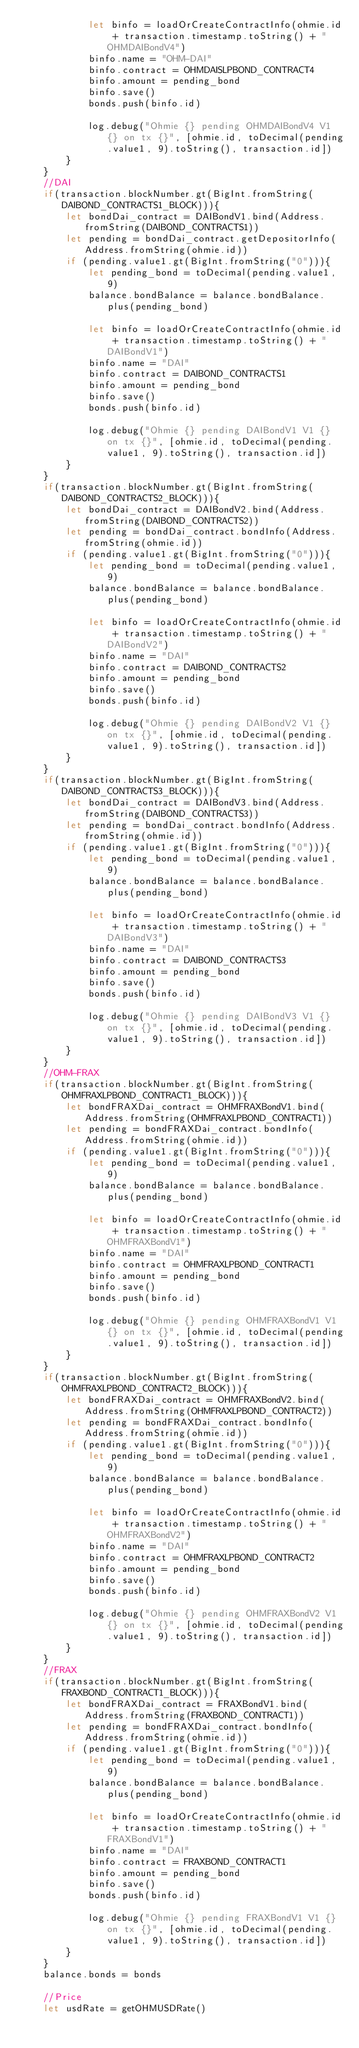<code> <loc_0><loc_0><loc_500><loc_500><_TypeScript_>            let binfo = loadOrCreateContractInfo(ohmie.id + transaction.timestamp.toString() + "OHMDAIBondV4")
            binfo.name = "OHM-DAI"
            binfo.contract = OHMDAISLPBOND_CONTRACT4
            binfo.amount = pending_bond
            binfo.save()
            bonds.push(binfo.id)

            log.debug("Ohmie {} pending OHMDAIBondV4 V1 {} on tx {}", [ohmie.id, toDecimal(pending.value1, 9).toString(), transaction.id])
        }
    }
    //DAI
    if(transaction.blockNumber.gt(BigInt.fromString(DAIBOND_CONTRACTS1_BLOCK))){
        let bondDai_contract = DAIBondV1.bind(Address.fromString(DAIBOND_CONTRACTS1))
        let pending = bondDai_contract.getDepositorInfo(Address.fromString(ohmie.id))
        if (pending.value1.gt(BigInt.fromString("0"))){
            let pending_bond = toDecimal(pending.value1, 9)
            balance.bondBalance = balance.bondBalance.plus(pending_bond)

            let binfo = loadOrCreateContractInfo(ohmie.id + transaction.timestamp.toString() + "DAIBondV1")
            binfo.name = "DAI"
            binfo.contract = DAIBOND_CONTRACTS1
            binfo.amount = pending_bond
            binfo.save()
            bonds.push(binfo.id)

            log.debug("Ohmie {} pending DAIBondV1 V1 {} on tx {}", [ohmie.id, toDecimal(pending.value1, 9).toString(), transaction.id])
        }
    }
    if(transaction.blockNumber.gt(BigInt.fromString(DAIBOND_CONTRACTS2_BLOCK))){
        let bondDai_contract = DAIBondV2.bind(Address.fromString(DAIBOND_CONTRACTS2))
        let pending = bondDai_contract.bondInfo(Address.fromString(ohmie.id))
        if (pending.value1.gt(BigInt.fromString("0"))){
            let pending_bond = toDecimal(pending.value1, 9)
            balance.bondBalance = balance.bondBalance.plus(pending_bond)

            let binfo = loadOrCreateContractInfo(ohmie.id + transaction.timestamp.toString() + "DAIBondV2")
            binfo.name = "DAI"
            binfo.contract = DAIBOND_CONTRACTS2
            binfo.amount = pending_bond
            binfo.save()
            bonds.push(binfo.id)

            log.debug("Ohmie {} pending DAIBondV2 V1 {} on tx {}", [ohmie.id, toDecimal(pending.value1, 9).toString(), transaction.id])
        }
    }
    if(transaction.blockNumber.gt(BigInt.fromString(DAIBOND_CONTRACTS3_BLOCK))){
        let bondDai_contract = DAIBondV3.bind(Address.fromString(DAIBOND_CONTRACTS3))
        let pending = bondDai_contract.bondInfo(Address.fromString(ohmie.id))
        if (pending.value1.gt(BigInt.fromString("0"))){
            let pending_bond = toDecimal(pending.value1, 9)
            balance.bondBalance = balance.bondBalance.plus(pending_bond)

            let binfo = loadOrCreateContractInfo(ohmie.id + transaction.timestamp.toString() + "DAIBondV3")
            binfo.name = "DAI"
            binfo.contract = DAIBOND_CONTRACTS3
            binfo.amount = pending_bond
            binfo.save()
            bonds.push(binfo.id)

            log.debug("Ohmie {} pending DAIBondV3 V1 {} on tx {}", [ohmie.id, toDecimal(pending.value1, 9).toString(), transaction.id])
        }
    }
    //OHM-FRAX
    if(transaction.blockNumber.gt(BigInt.fromString(OHMFRAXLPBOND_CONTRACT1_BLOCK))){
        let bondFRAXDai_contract = OHMFRAXBondV1.bind(Address.fromString(OHMFRAXLPBOND_CONTRACT1))
        let pending = bondFRAXDai_contract.bondInfo(Address.fromString(ohmie.id))
        if (pending.value1.gt(BigInt.fromString("0"))){
            let pending_bond = toDecimal(pending.value1, 9)
            balance.bondBalance = balance.bondBalance.plus(pending_bond)

            let binfo = loadOrCreateContractInfo(ohmie.id + transaction.timestamp.toString() + "OHMFRAXBondV1")
            binfo.name = "DAI"
            binfo.contract = OHMFRAXLPBOND_CONTRACT1
            binfo.amount = pending_bond
            binfo.save()
            bonds.push(binfo.id)

            log.debug("Ohmie {} pending OHMFRAXBondV1 V1 {} on tx {}", [ohmie.id, toDecimal(pending.value1, 9).toString(), transaction.id])
        }
    }
    if(transaction.blockNumber.gt(BigInt.fromString(OHMFRAXLPBOND_CONTRACT2_BLOCK))){
        let bondFRAXDai_contract = OHMFRAXBondV2.bind(Address.fromString(OHMFRAXLPBOND_CONTRACT2))
        let pending = bondFRAXDai_contract.bondInfo(Address.fromString(ohmie.id))
        if (pending.value1.gt(BigInt.fromString("0"))){
            let pending_bond = toDecimal(pending.value1, 9)
            balance.bondBalance = balance.bondBalance.plus(pending_bond)

            let binfo = loadOrCreateContractInfo(ohmie.id + transaction.timestamp.toString() + "OHMFRAXBondV2")
            binfo.name = "DAI"
            binfo.contract = OHMFRAXLPBOND_CONTRACT2
            binfo.amount = pending_bond
            binfo.save()
            bonds.push(binfo.id)

            log.debug("Ohmie {} pending OHMFRAXBondV2 V1 {} on tx {}", [ohmie.id, toDecimal(pending.value1, 9).toString(), transaction.id])
        }
    }
    //FRAX
    if(transaction.blockNumber.gt(BigInt.fromString(FRAXBOND_CONTRACT1_BLOCK))){
        let bondFRAXDai_contract = FRAXBondV1.bind(Address.fromString(FRAXBOND_CONTRACT1))
        let pending = bondFRAXDai_contract.bondInfo(Address.fromString(ohmie.id))
        if (pending.value1.gt(BigInt.fromString("0"))){
            let pending_bond = toDecimal(pending.value1, 9)
            balance.bondBalance = balance.bondBalance.plus(pending_bond)

            let binfo = loadOrCreateContractInfo(ohmie.id + transaction.timestamp.toString() + "FRAXBondV1")
            binfo.name = "DAI"
            binfo.contract = FRAXBOND_CONTRACT1
            binfo.amount = pending_bond
            binfo.save()
            bonds.push(binfo.id)

            log.debug("Ohmie {} pending FRAXBondV1 V1 {} on tx {}", [ohmie.id, toDecimal(pending.value1, 9).toString(), transaction.id])
        }
    }
    balance.bonds = bonds

    //Price
    let usdRate = getOHMUSDRate()</code> 